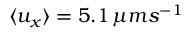Convert formula to latex. <formula><loc_0><loc_0><loc_500><loc_500>\langle u _ { x } \rangle = 5 . 1 \, \mu m s ^ { - 1 }</formula> 